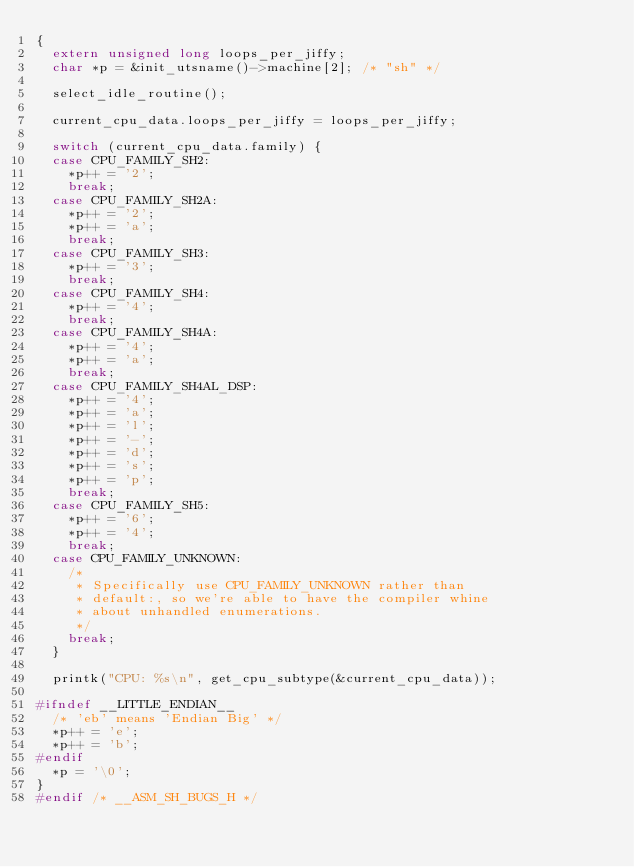Convert code to text. <code><loc_0><loc_0><loc_500><loc_500><_C_>{
	extern unsigned long loops_per_jiffy;
	char *p = &init_utsname()->machine[2]; /* "sh" */

	select_idle_routine();

	current_cpu_data.loops_per_jiffy = loops_per_jiffy;

	switch (current_cpu_data.family) {
	case CPU_FAMILY_SH2:
		*p++ = '2';
		break;
	case CPU_FAMILY_SH2A:
		*p++ = '2';
		*p++ = 'a';
		break;
	case CPU_FAMILY_SH3:
		*p++ = '3';
		break;
	case CPU_FAMILY_SH4:
		*p++ = '4';
		break;
	case CPU_FAMILY_SH4A:
		*p++ = '4';
		*p++ = 'a';
		break;
	case CPU_FAMILY_SH4AL_DSP:
		*p++ = '4';
		*p++ = 'a';
		*p++ = 'l';
		*p++ = '-';
		*p++ = 'd';
		*p++ = 's';
		*p++ = 'p';
		break;
	case CPU_FAMILY_SH5:
		*p++ = '6';
		*p++ = '4';
		break;
	case CPU_FAMILY_UNKNOWN:
		/*
		 * Specifically use CPU_FAMILY_UNKNOWN rather than
		 * default:, so we're able to have the compiler whine
		 * about unhandled enumerations.
		 */
		break;
	}

	printk("CPU: %s\n", get_cpu_subtype(&current_cpu_data));

#ifndef __LITTLE_ENDIAN__
	/* 'eb' means 'Endian Big' */
	*p++ = 'e';
	*p++ = 'b';
#endif
	*p = '\0';
}
#endif /* __ASM_SH_BUGS_H */
</code> 